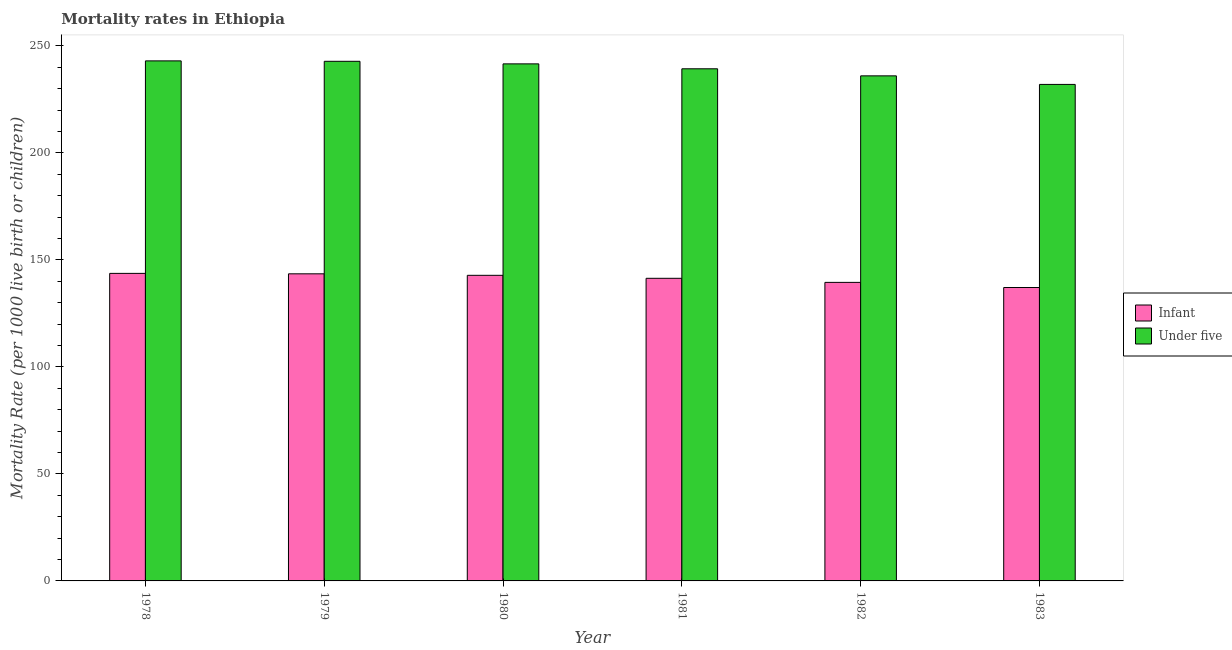Are the number of bars per tick equal to the number of legend labels?
Your answer should be compact. Yes. How many bars are there on the 5th tick from the left?
Offer a terse response. 2. How many bars are there on the 5th tick from the right?
Offer a terse response. 2. What is the label of the 6th group of bars from the left?
Make the answer very short. 1983. In how many cases, is the number of bars for a given year not equal to the number of legend labels?
Offer a terse response. 0. What is the under-5 mortality rate in 1979?
Give a very brief answer. 242.8. Across all years, what is the maximum under-5 mortality rate?
Ensure brevity in your answer.  243. Across all years, what is the minimum infant mortality rate?
Make the answer very short. 137.1. In which year was the under-5 mortality rate maximum?
Give a very brief answer. 1978. What is the total infant mortality rate in the graph?
Make the answer very short. 848. What is the difference between the under-5 mortality rate in 1981 and that in 1983?
Give a very brief answer. 7.3. What is the difference between the infant mortality rate in 1979 and the under-5 mortality rate in 1978?
Offer a very short reply. -0.2. What is the average under-5 mortality rate per year?
Keep it short and to the point. 239.12. In the year 1981, what is the difference between the infant mortality rate and under-5 mortality rate?
Give a very brief answer. 0. What is the ratio of the under-5 mortality rate in 1981 to that in 1982?
Offer a very short reply. 1.01. Is the difference between the under-5 mortality rate in 1981 and 1983 greater than the difference between the infant mortality rate in 1981 and 1983?
Your response must be concise. No. What is the difference between the highest and the second highest under-5 mortality rate?
Your answer should be compact. 0.2. Is the sum of the under-5 mortality rate in 1979 and 1982 greater than the maximum infant mortality rate across all years?
Make the answer very short. Yes. What does the 2nd bar from the left in 1981 represents?
Offer a terse response. Under five. What does the 1st bar from the right in 1980 represents?
Offer a very short reply. Under five. How many bars are there?
Your answer should be compact. 12. What is the difference between two consecutive major ticks on the Y-axis?
Give a very brief answer. 50. Are the values on the major ticks of Y-axis written in scientific E-notation?
Your answer should be compact. No. Does the graph contain grids?
Ensure brevity in your answer.  No. How are the legend labels stacked?
Offer a very short reply. Vertical. What is the title of the graph?
Your answer should be compact. Mortality rates in Ethiopia. What is the label or title of the X-axis?
Your answer should be compact. Year. What is the label or title of the Y-axis?
Provide a short and direct response. Mortality Rate (per 1000 live birth or children). What is the Mortality Rate (per 1000 live birth or children) in Infant in 1978?
Ensure brevity in your answer.  143.7. What is the Mortality Rate (per 1000 live birth or children) of Under five in 1978?
Offer a very short reply. 243. What is the Mortality Rate (per 1000 live birth or children) in Infant in 1979?
Offer a terse response. 143.5. What is the Mortality Rate (per 1000 live birth or children) of Under five in 1979?
Your answer should be compact. 242.8. What is the Mortality Rate (per 1000 live birth or children) of Infant in 1980?
Provide a succinct answer. 142.8. What is the Mortality Rate (per 1000 live birth or children) in Under five in 1980?
Provide a short and direct response. 241.6. What is the Mortality Rate (per 1000 live birth or children) of Infant in 1981?
Keep it short and to the point. 141.4. What is the Mortality Rate (per 1000 live birth or children) in Under five in 1981?
Give a very brief answer. 239.3. What is the Mortality Rate (per 1000 live birth or children) of Infant in 1982?
Your response must be concise. 139.5. What is the Mortality Rate (per 1000 live birth or children) of Under five in 1982?
Provide a succinct answer. 236. What is the Mortality Rate (per 1000 live birth or children) in Infant in 1983?
Your answer should be very brief. 137.1. What is the Mortality Rate (per 1000 live birth or children) of Under five in 1983?
Ensure brevity in your answer.  232. Across all years, what is the maximum Mortality Rate (per 1000 live birth or children) in Infant?
Your answer should be very brief. 143.7. Across all years, what is the maximum Mortality Rate (per 1000 live birth or children) of Under five?
Keep it short and to the point. 243. Across all years, what is the minimum Mortality Rate (per 1000 live birth or children) of Infant?
Offer a very short reply. 137.1. Across all years, what is the minimum Mortality Rate (per 1000 live birth or children) in Under five?
Ensure brevity in your answer.  232. What is the total Mortality Rate (per 1000 live birth or children) in Infant in the graph?
Your answer should be compact. 848. What is the total Mortality Rate (per 1000 live birth or children) of Under five in the graph?
Provide a succinct answer. 1434.7. What is the difference between the Mortality Rate (per 1000 live birth or children) of Infant in 1978 and that in 1979?
Offer a very short reply. 0.2. What is the difference between the Mortality Rate (per 1000 live birth or children) of Under five in 1978 and that in 1979?
Offer a very short reply. 0.2. What is the difference between the Mortality Rate (per 1000 live birth or children) of Infant in 1978 and that in 1980?
Offer a terse response. 0.9. What is the difference between the Mortality Rate (per 1000 live birth or children) in Under five in 1978 and that in 1980?
Your answer should be compact. 1.4. What is the difference between the Mortality Rate (per 1000 live birth or children) in Under five in 1978 and that in 1983?
Your answer should be compact. 11. What is the difference between the Mortality Rate (per 1000 live birth or children) in Infant in 1979 and that in 1980?
Make the answer very short. 0.7. What is the difference between the Mortality Rate (per 1000 live birth or children) of Infant in 1979 and that in 1981?
Your answer should be compact. 2.1. What is the difference between the Mortality Rate (per 1000 live birth or children) of Under five in 1979 and that in 1982?
Keep it short and to the point. 6.8. What is the difference between the Mortality Rate (per 1000 live birth or children) in Infant in 1979 and that in 1983?
Keep it short and to the point. 6.4. What is the difference between the Mortality Rate (per 1000 live birth or children) in Under five in 1979 and that in 1983?
Ensure brevity in your answer.  10.8. What is the difference between the Mortality Rate (per 1000 live birth or children) in Infant in 1980 and that in 1981?
Your answer should be very brief. 1.4. What is the difference between the Mortality Rate (per 1000 live birth or children) of Under five in 1980 and that in 1983?
Ensure brevity in your answer.  9.6. What is the difference between the Mortality Rate (per 1000 live birth or children) in Under five in 1981 and that in 1982?
Your answer should be very brief. 3.3. What is the difference between the Mortality Rate (per 1000 live birth or children) in Infant in 1981 and that in 1983?
Keep it short and to the point. 4.3. What is the difference between the Mortality Rate (per 1000 live birth or children) of Under five in 1981 and that in 1983?
Offer a very short reply. 7.3. What is the difference between the Mortality Rate (per 1000 live birth or children) of Infant in 1982 and that in 1983?
Provide a short and direct response. 2.4. What is the difference between the Mortality Rate (per 1000 live birth or children) in Infant in 1978 and the Mortality Rate (per 1000 live birth or children) in Under five in 1979?
Your response must be concise. -99.1. What is the difference between the Mortality Rate (per 1000 live birth or children) of Infant in 1978 and the Mortality Rate (per 1000 live birth or children) of Under five in 1980?
Provide a short and direct response. -97.9. What is the difference between the Mortality Rate (per 1000 live birth or children) in Infant in 1978 and the Mortality Rate (per 1000 live birth or children) in Under five in 1981?
Give a very brief answer. -95.6. What is the difference between the Mortality Rate (per 1000 live birth or children) of Infant in 1978 and the Mortality Rate (per 1000 live birth or children) of Under five in 1982?
Keep it short and to the point. -92.3. What is the difference between the Mortality Rate (per 1000 live birth or children) of Infant in 1978 and the Mortality Rate (per 1000 live birth or children) of Under five in 1983?
Ensure brevity in your answer.  -88.3. What is the difference between the Mortality Rate (per 1000 live birth or children) of Infant in 1979 and the Mortality Rate (per 1000 live birth or children) of Under five in 1980?
Your answer should be very brief. -98.1. What is the difference between the Mortality Rate (per 1000 live birth or children) of Infant in 1979 and the Mortality Rate (per 1000 live birth or children) of Under five in 1981?
Provide a succinct answer. -95.8. What is the difference between the Mortality Rate (per 1000 live birth or children) in Infant in 1979 and the Mortality Rate (per 1000 live birth or children) in Under five in 1982?
Your answer should be compact. -92.5. What is the difference between the Mortality Rate (per 1000 live birth or children) of Infant in 1979 and the Mortality Rate (per 1000 live birth or children) of Under five in 1983?
Your response must be concise. -88.5. What is the difference between the Mortality Rate (per 1000 live birth or children) of Infant in 1980 and the Mortality Rate (per 1000 live birth or children) of Under five in 1981?
Keep it short and to the point. -96.5. What is the difference between the Mortality Rate (per 1000 live birth or children) in Infant in 1980 and the Mortality Rate (per 1000 live birth or children) in Under five in 1982?
Offer a very short reply. -93.2. What is the difference between the Mortality Rate (per 1000 live birth or children) of Infant in 1980 and the Mortality Rate (per 1000 live birth or children) of Under five in 1983?
Ensure brevity in your answer.  -89.2. What is the difference between the Mortality Rate (per 1000 live birth or children) of Infant in 1981 and the Mortality Rate (per 1000 live birth or children) of Under five in 1982?
Keep it short and to the point. -94.6. What is the difference between the Mortality Rate (per 1000 live birth or children) in Infant in 1981 and the Mortality Rate (per 1000 live birth or children) in Under five in 1983?
Ensure brevity in your answer.  -90.6. What is the difference between the Mortality Rate (per 1000 live birth or children) of Infant in 1982 and the Mortality Rate (per 1000 live birth or children) of Under five in 1983?
Give a very brief answer. -92.5. What is the average Mortality Rate (per 1000 live birth or children) in Infant per year?
Your response must be concise. 141.33. What is the average Mortality Rate (per 1000 live birth or children) in Under five per year?
Offer a very short reply. 239.12. In the year 1978, what is the difference between the Mortality Rate (per 1000 live birth or children) in Infant and Mortality Rate (per 1000 live birth or children) in Under five?
Offer a very short reply. -99.3. In the year 1979, what is the difference between the Mortality Rate (per 1000 live birth or children) of Infant and Mortality Rate (per 1000 live birth or children) of Under five?
Make the answer very short. -99.3. In the year 1980, what is the difference between the Mortality Rate (per 1000 live birth or children) of Infant and Mortality Rate (per 1000 live birth or children) of Under five?
Keep it short and to the point. -98.8. In the year 1981, what is the difference between the Mortality Rate (per 1000 live birth or children) of Infant and Mortality Rate (per 1000 live birth or children) of Under five?
Make the answer very short. -97.9. In the year 1982, what is the difference between the Mortality Rate (per 1000 live birth or children) in Infant and Mortality Rate (per 1000 live birth or children) in Under five?
Offer a very short reply. -96.5. In the year 1983, what is the difference between the Mortality Rate (per 1000 live birth or children) of Infant and Mortality Rate (per 1000 live birth or children) of Under five?
Your answer should be compact. -94.9. What is the ratio of the Mortality Rate (per 1000 live birth or children) of Infant in 1978 to that in 1981?
Provide a short and direct response. 1.02. What is the ratio of the Mortality Rate (per 1000 live birth or children) of Under five in 1978 to that in 1981?
Your answer should be compact. 1.02. What is the ratio of the Mortality Rate (per 1000 live birth or children) in Infant in 1978 to that in 1982?
Provide a short and direct response. 1.03. What is the ratio of the Mortality Rate (per 1000 live birth or children) of Under five in 1978 to that in 1982?
Your answer should be very brief. 1.03. What is the ratio of the Mortality Rate (per 1000 live birth or children) in Infant in 1978 to that in 1983?
Your response must be concise. 1.05. What is the ratio of the Mortality Rate (per 1000 live birth or children) of Under five in 1978 to that in 1983?
Ensure brevity in your answer.  1.05. What is the ratio of the Mortality Rate (per 1000 live birth or children) in Infant in 1979 to that in 1980?
Provide a short and direct response. 1. What is the ratio of the Mortality Rate (per 1000 live birth or children) of Under five in 1979 to that in 1980?
Offer a very short reply. 1. What is the ratio of the Mortality Rate (per 1000 live birth or children) of Infant in 1979 to that in 1981?
Ensure brevity in your answer.  1.01. What is the ratio of the Mortality Rate (per 1000 live birth or children) of Under five in 1979 to that in 1981?
Make the answer very short. 1.01. What is the ratio of the Mortality Rate (per 1000 live birth or children) of Infant in 1979 to that in 1982?
Your answer should be compact. 1.03. What is the ratio of the Mortality Rate (per 1000 live birth or children) of Under five in 1979 to that in 1982?
Provide a succinct answer. 1.03. What is the ratio of the Mortality Rate (per 1000 live birth or children) in Infant in 1979 to that in 1983?
Provide a short and direct response. 1.05. What is the ratio of the Mortality Rate (per 1000 live birth or children) of Under five in 1979 to that in 1983?
Your answer should be very brief. 1.05. What is the ratio of the Mortality Rate (per 1000 live birth or children) in Infant in 1980 to that in 1981?
Give a very brief answer. 1.01. What is the ratio of the Mortality Rate (per 1000 live birth or children) of Under five in 1980 to that in 1981?
Your answer should be very brief. 1.01. What is the ratio of the Mortality Rate (per 1000 live birth or children) in Infant in 1980 to that in 1982?
Provide a succinct answer. 1.02. What is the ratio of the Mortality Rate (per 1000 live birth or children) in Under five in 1980 to that in 1982?
Offer a very short reply. 1.02. What is the ratio of the Mortality Rate (per 1000 live birth or children) of Infant in 1980 to that in 1983?
Offer a very short reply. 1.04. What is the ratio of the Mortality Rate (per 1000 live birth or children) of Under five in 1980 to that in 1983?
Offer a terse response. 1.04. What is the ratio of the Mortality Rate (per 1000 live birth or children) of Infant in 1981 to that in 1982?
Give a very brief answer. 1.01. What is the ratio of the Mortality Rate (per 1000 live birth or children) in Under five in 1981 to that in 1982?
Provide a succinct answer. 1.01. What is the ratio of the Mortality Rate (per 1000 live birth or children) of Infant in 1981 to that in 1983?
Ensure brevity in your answer.  1.03. What is the ratio of the Mortality Rate (per 1000 live birth or children) in Under five in 1981 to that in 1983?
Offer a very short reply. 1.03. What is the ratio of the Mortality Rate (per 1000 live birth or children) of Infant in 1982 to that in 1983?
Your answer should be very brief. 1.02. What is the ratio of the Mortality Rate (per 1000 live birth or children) of Under five in 1982 to that in 1983?
Offer a terse response. 1.02. What is the difference between the highest and the lowest Mortality Rate (per 1000 live birth or children) of Infant?
Provide a short and direct response. 6.6. What is the difference between the highest and the lowest Mortality Rate (per 1000 live birth or children) in Under five?
Offer a very short reply. 11. 